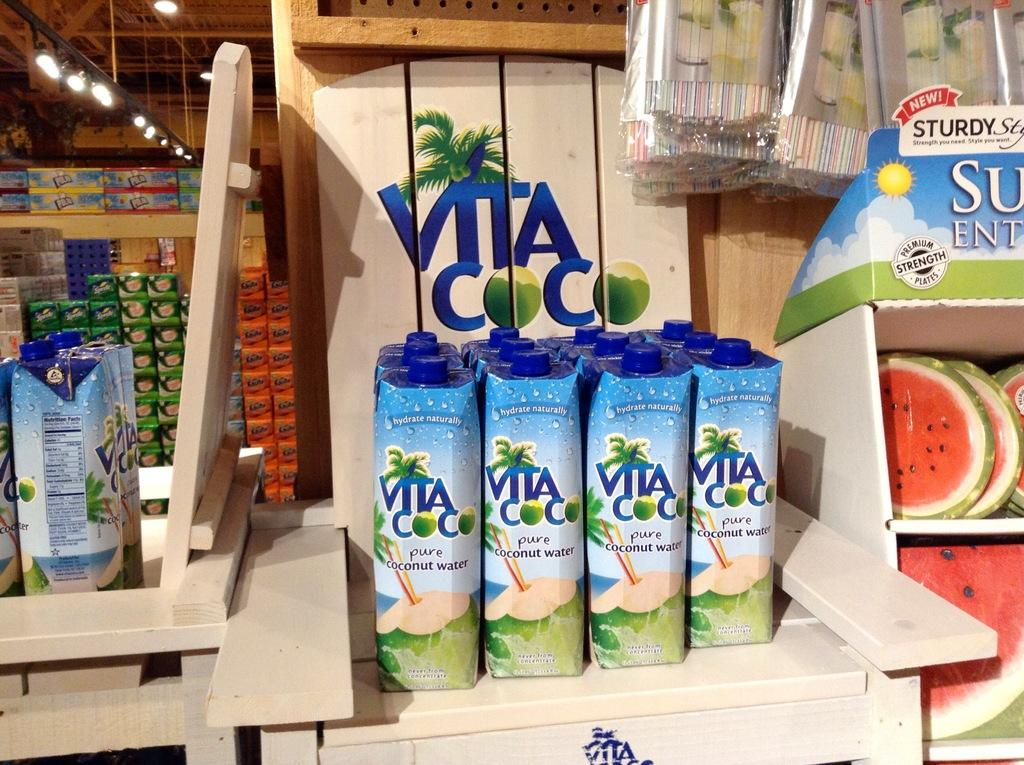<image>
Offer a succinct explanation of the picture presented. A store shelf contains a product which is named Vita Coco. 